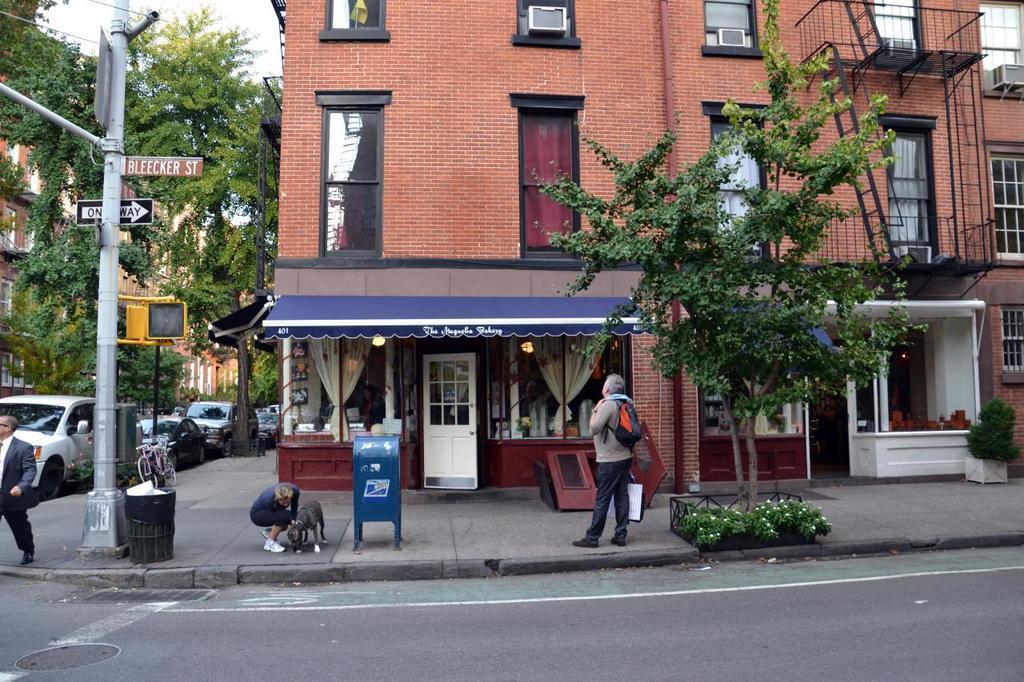Please provide a concise description of this image. In this picture there is a building in the center of the image, on which there are windows and there are cars on the left side of the image, there is a sign pole on the left side of the image, there are people in the image, there is a stall in the center of the image and there are dustbins in the image, there are ladders at the top side of the image and there are trees and other buildings in the image. 